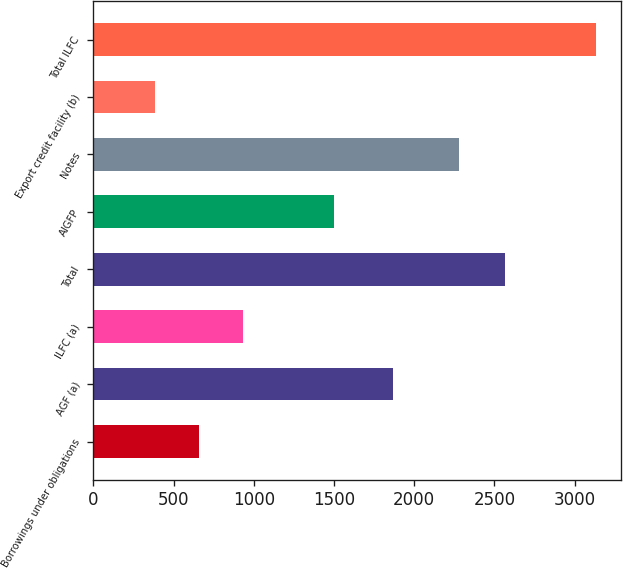<chart> <loc_0><loc_0><loc_500><loc_500><bar_chart><fcel>Borrowings under obligations<fcel>AGF (a)<fcel>ILFC (a)<fcel>Total<fcel>AIGFP<fcel>Notes<fcel>Export credit facility (b)<fcel>Total ILFC<nl><fcel>656.3<fcel>1866<fcel>931.6<fcel>2566<fcel>1498<fcel>2282<fcel>381<fcel>3134<nl></chart> 